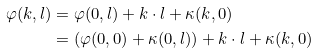Convert formula to latex. <formula><loc_0><loc_0><loc_500><loc_500>\varphi ( k , l ) & = \varphi ( 0 , l ) + k \cdot l + \kappa ( k , 0 ) \\ & = \left ( \varphi ( 0 , 0 ) + \kappa ( 0 , l ) \right ) + k \cdot l + \kappa ( k , 0 )</formula> 